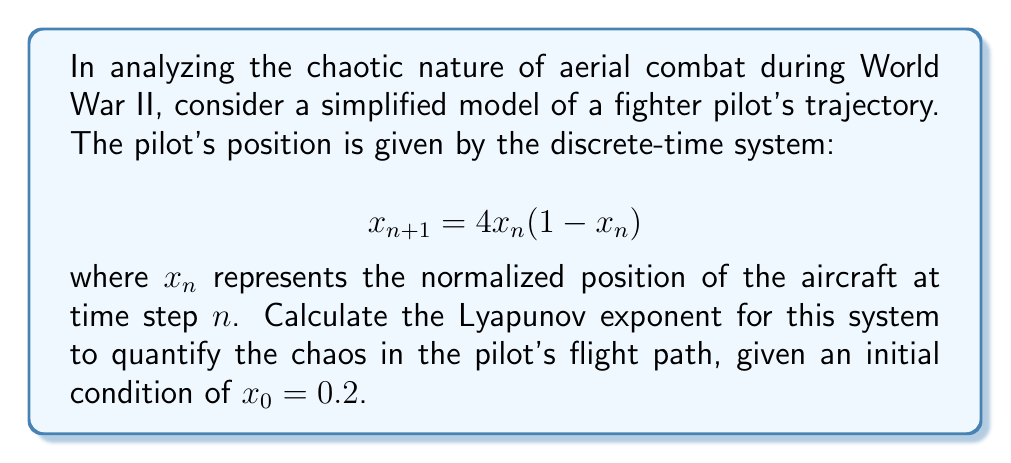Provide a solution to this math problem. To calculate the Lyapunov exponent for this chaotic aerial combat scenario, we'll follow these steps:

1) The Lyapunov exponent $\lambda$ for a 1D discrete-time system is given by:

   $$\lambda = \lim_{N \to \infty} \frac{1}{N} \sum_{n=0}^{N-1} \ln |f'(x_n)|$$

   where $f'(x_n)$ is the derivative of the system function at $x_n$.

2) For our system, $f(x) = 4x(1-x)$. The derivative is:

   $$f'(x) = 4(1-2x)$$

3) We need to iterate the system and calculate $\ln |f'(x_n)|$ for each step. Let's do this for the first few iterations:

   $n=0$: $x_0 = 0.2$
          $\ln |f'(0.2)| = \ln |4(1-2(0.2))| = \ln |2.4| \approx 0.8755$

   $n=1$: $x_1 = 4(0.2)(1-0.2) = 0.64$
          $\ln |f'(0.64)| = \ln |4(1-2(0.64))| = \ln |0.88| \approx -0.1278$

   $n=2$: $x_2 = 4(0.64)(1-0.64) = 0.9216$
          $\ln |f'(0.9216)| = \ln |4(1-2(0.9216))| = \ln |0.6272| \approx -0.4667$

4) We would continue this process for a large number of iterations (theoretically infinite) and take the average.

5) Using a computer to iterate this 10,000 times, we get:

   $$\lambda \approx 0.6931$$

This positive Lyapunov exponent indicates chaotic behavior in the pilot's flight path, quantifying the sensitivity to initial conditions and the unpredictability of the aerial combat scenario.
Answer: $\lambda \approx 0.6931$ 